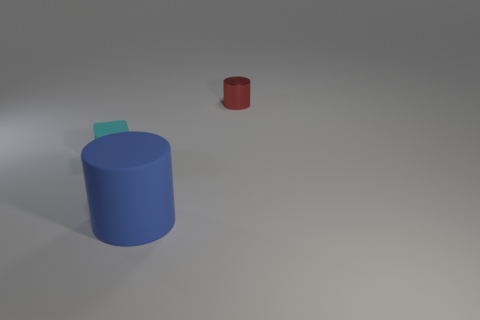Are there any other things that are made of the same material as the tiny red thing?
Make the answer very short. No. The cylinder that is in front of the small cube to the left of the big blue object is made of what material?
Ensure brevity in your answer.  Rubber. Do the matte thing right of the tiny cyan rubber thing and the matte object that is behind the big rubber object have the same size?
Offer a terse response. No. How many tiny objects are either cyan things or metal objects?
Your answer should be compact. 2. What number of things are small things that are to the left of the small metal thing or tiny cubes?
Your answer should be compact. 1. Does the tiny cylinder have the same color as the big object?
Ensure brevity in your answer.  No. What number of other things are there of the same shape as the tiny cyan matte thing?
Your answer should be very brief. 0. How many blue objects are tiny rubber objects or rubber cylinders?
Make the answer very short. 1. What color is the big thing that is the same material as the tiny block?
Keep it short and to the point. Blue. Is the material of the cylinder in front of the small block the same as the small object that is left of the metallic cylinder?
Give a very brief answer. Yes. 